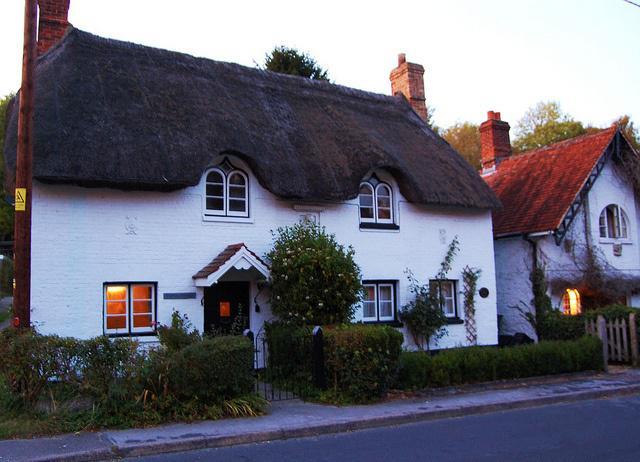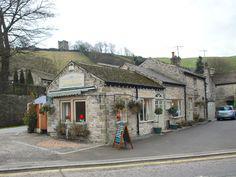The first image is the image on the left, the second image is the image on the right. Given the left and right images, does the statement "In at least one image, there are at least two homes with white walls." hold true? Answer yes or no. Yes. The first image is the image on the left, the second image is the image on the right. For the images displayed, is the sentence "People are standing in front of one of the buildings." factually correct? Answer yes or no. No. 